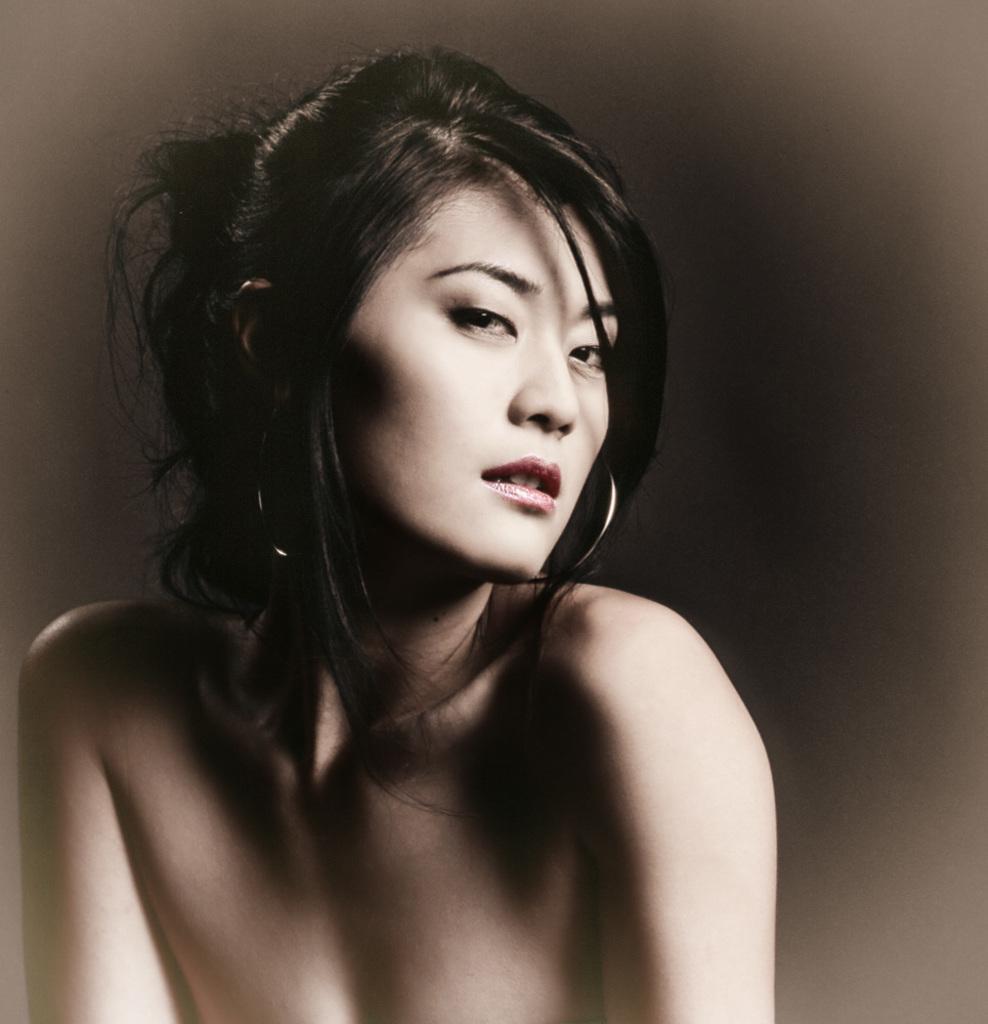Can you describe this image briefly? In this match there is a girl posing for the camera. 